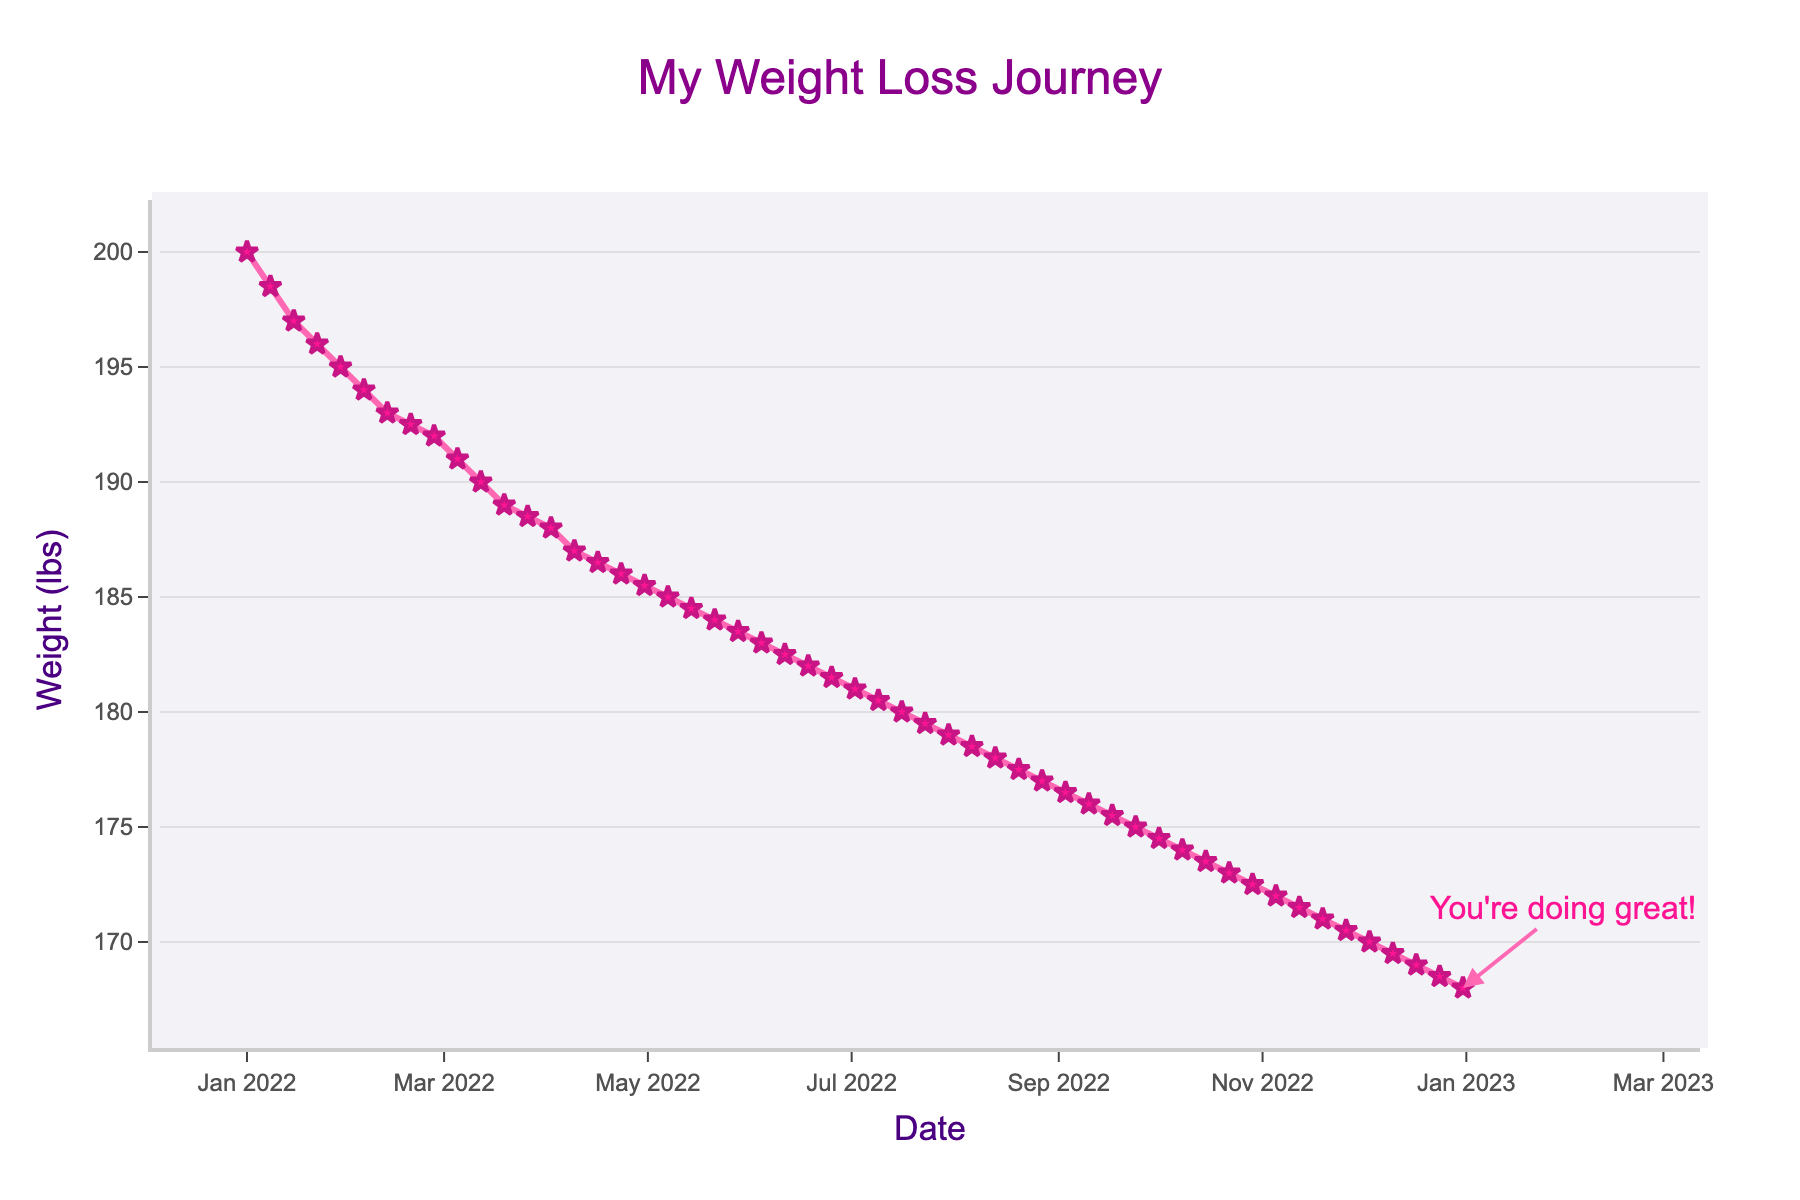What is the title of the plot? The title of the plot is written in a large, colorful font at the top of the figure. It reads "My Weight Loss Journey" with specific alignment and stylistic customizations.
Answer: My Weight Loss Journey What is the weight recorded on March 5, 2022? Look at the x-axis to find the date March 5, 2022, and then trace upwards vertically to find the corresponding weight on the y-axis. The weight recorded on that date is 191 lbs.
Answer: 191 lbs How much weight did I lose from January 1, 2022, to December 31, 2022? Identify and note the initial weight on January 1, 2022 (200 lbs) and the final weight on December 31, 2022 (168 lbs). Subtract the final weight from the initial weight: 200 - 168 = 32 lbs.
Answer: 32 lbs What was my average weight loss per month? Begin with the total weight lost over 12 months, which is 32 lbs. Since there are 12 months, divide the total weight loss by 12: 32 lbs / 12 months = approximately 2.67 lbs per month.
Answer: 2.67 lbs/month Did I experience any weeks where my weight increased? If yes, how many times? Examine the plot line for any upward trends (points where weight increases from a previous week). Weigh increases are noted from January 1 (200 lbs) to January 8 (198.5 lbs), February 12 (193 lbs) to February 19 (192.5 lbs). Each upward point represents an increase in weight. Check each month sequentially for precision. A total of 2 occurrences show weight increases.
Answer: Yes, 2 times Which month had the highest weight loss? Compare the weight loss for each month by checking the starting and ending weights for each month. The highest weight loss occurred from January 1, 2022 (200 lbs) to January 29, 2022 (195 lbs), totaling a 5 lbs loss.
Answer: January What does the annotation at the end of the plot say? At the end of the plot, there is an annotation pointing to the final data point. The annotation reads "You're doing great!"
Answer: You're doing great! Which week in April showed the smallest weight change? Examine the plotted points in April and compare the changes in weight between consecutive weeks. The smallest change appears between April 16 (186.5 lbs) and April 23 (186 lbs), a difference of 0.5 lbs.
Answer: April 16 to April 23 Is there an overall trend in the weight loss over the 12 months? Inspect the entire plot line from start to finish. The line generally moves downward from January to December, indicating an overall trend of weight loss.
Answer: Downward trend From July to August, which week had the largest weight decrease? Check the weight data points from July to August and find the week with the most significant drop by subtracting the previous week's weight from the current week's weight. The largest decrease is from July 23 (179.5 lbs) to July 30 (179 lbs), which is a 0.5 lb loss.
Answer: July 23 to July 30 